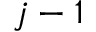<formula> <loc_0><loc_0><loc_500><loc_500>j - 1</formula> 